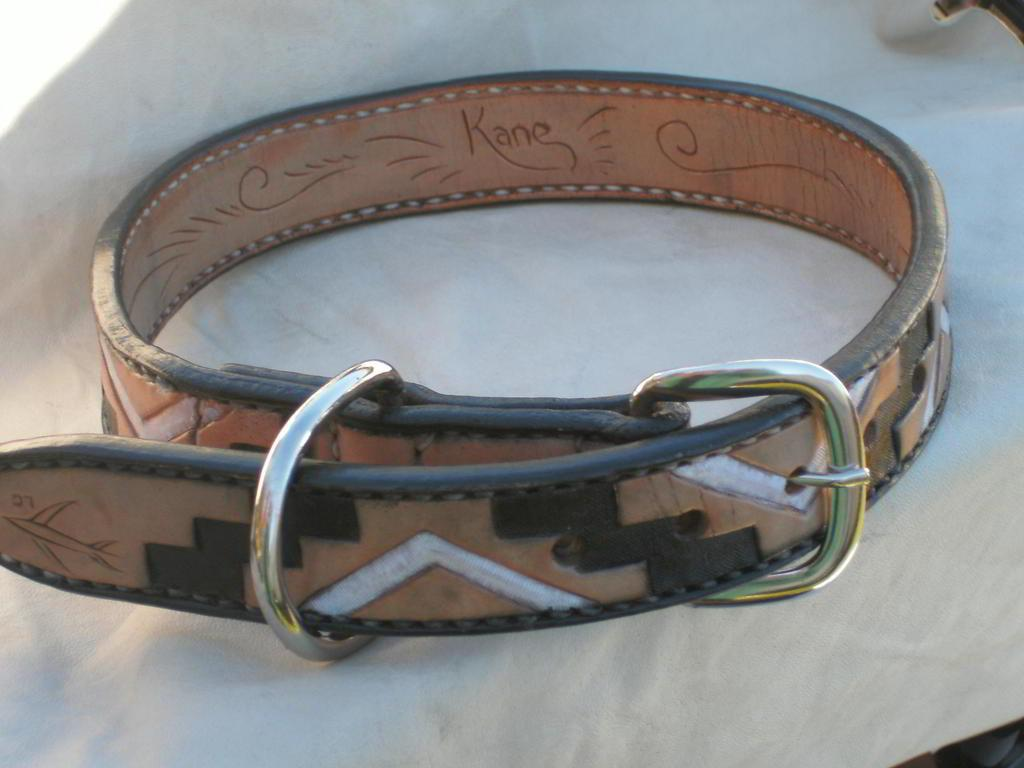<image>
Relay a brief, clear account of the picture shown. A leather belt with the name Kane on the inside is buckled. 